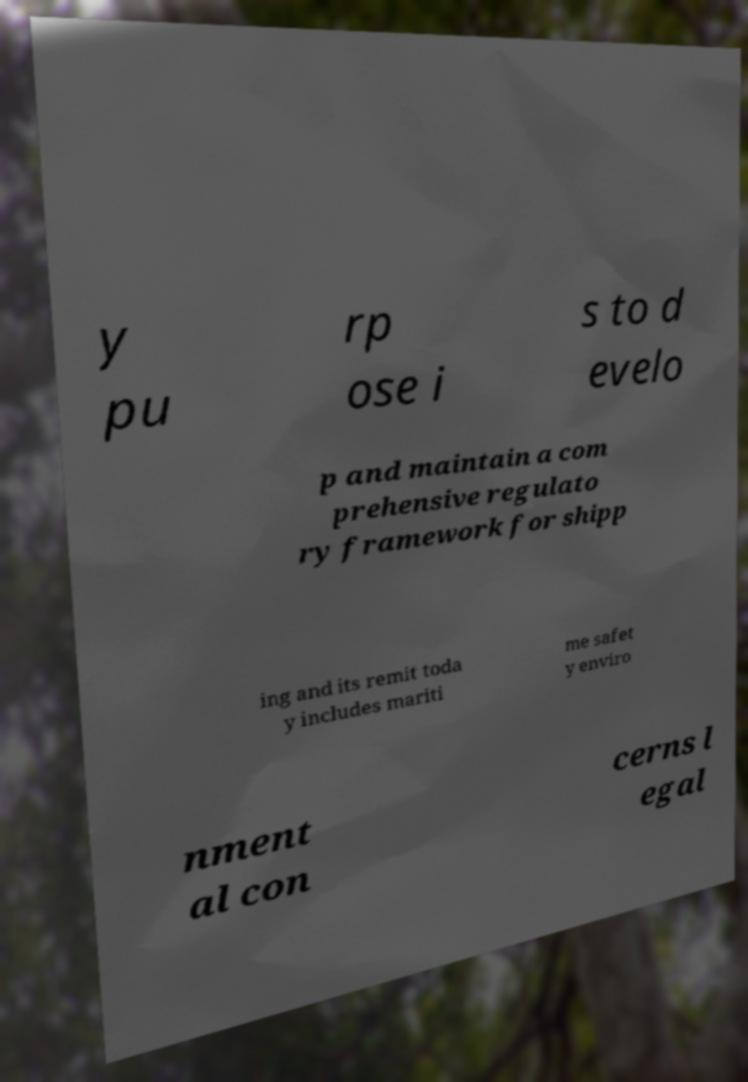For documentation purposes, I need the text within this image transcribed. Could you provide that? y pu rp ose i s to d evelo p and maintain a com prehensive regulato ry framework for shipp ing and its remit toda y includes mariti me safet y enviro nment al con cerns l egal 